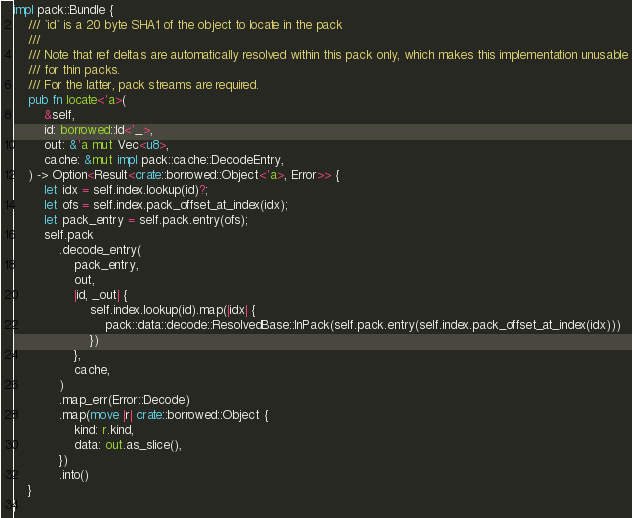<code> <loc_0><loc_0><loc_500><loc_500><_Rust_>impl pack::Bundle {
    /// `id` is a 20 byte SHA1 of the object to locate in the pack
    ///
    /// Note that ref deltas are automatically resolved within this pack only, which makes this implementation unusable
    /// for thin packs.
    /// For the latter, pack streams are required.
    pub fn locate<'a>(
        &self,
        id: borrowed::Id<'_>,
        out: &'a mut Vec<u8>,
        cache: &mut impl pack::cache::DecodeEntry,
    ) -> Option<Result<crate::borrowed::Object<'a>, Error>> {
        let idx = self.index.lookup(id)?;
        let ofs = self.index.pack_offset_at_index(idx);
        let pack_entry = self.pack.entry(ofs);
        self.pack
            .decode_entry(
                pack_entry,
                out,
                |id, _out| {
                    self.index.lookup(id).map(|idx| {
                        pack::data::decode::ResolvedBase::InPack(self.pack.entry(self.index.pack_offset_at_index(idx)))
                    })
                },
                cache,
            )
            .map_err(Error::Decode)
            .map(move |r| crate::borrowed::Object {
                kind: r.kind,
                data: out.as_slice(),
            })
            .into()
    }
}
</code> 